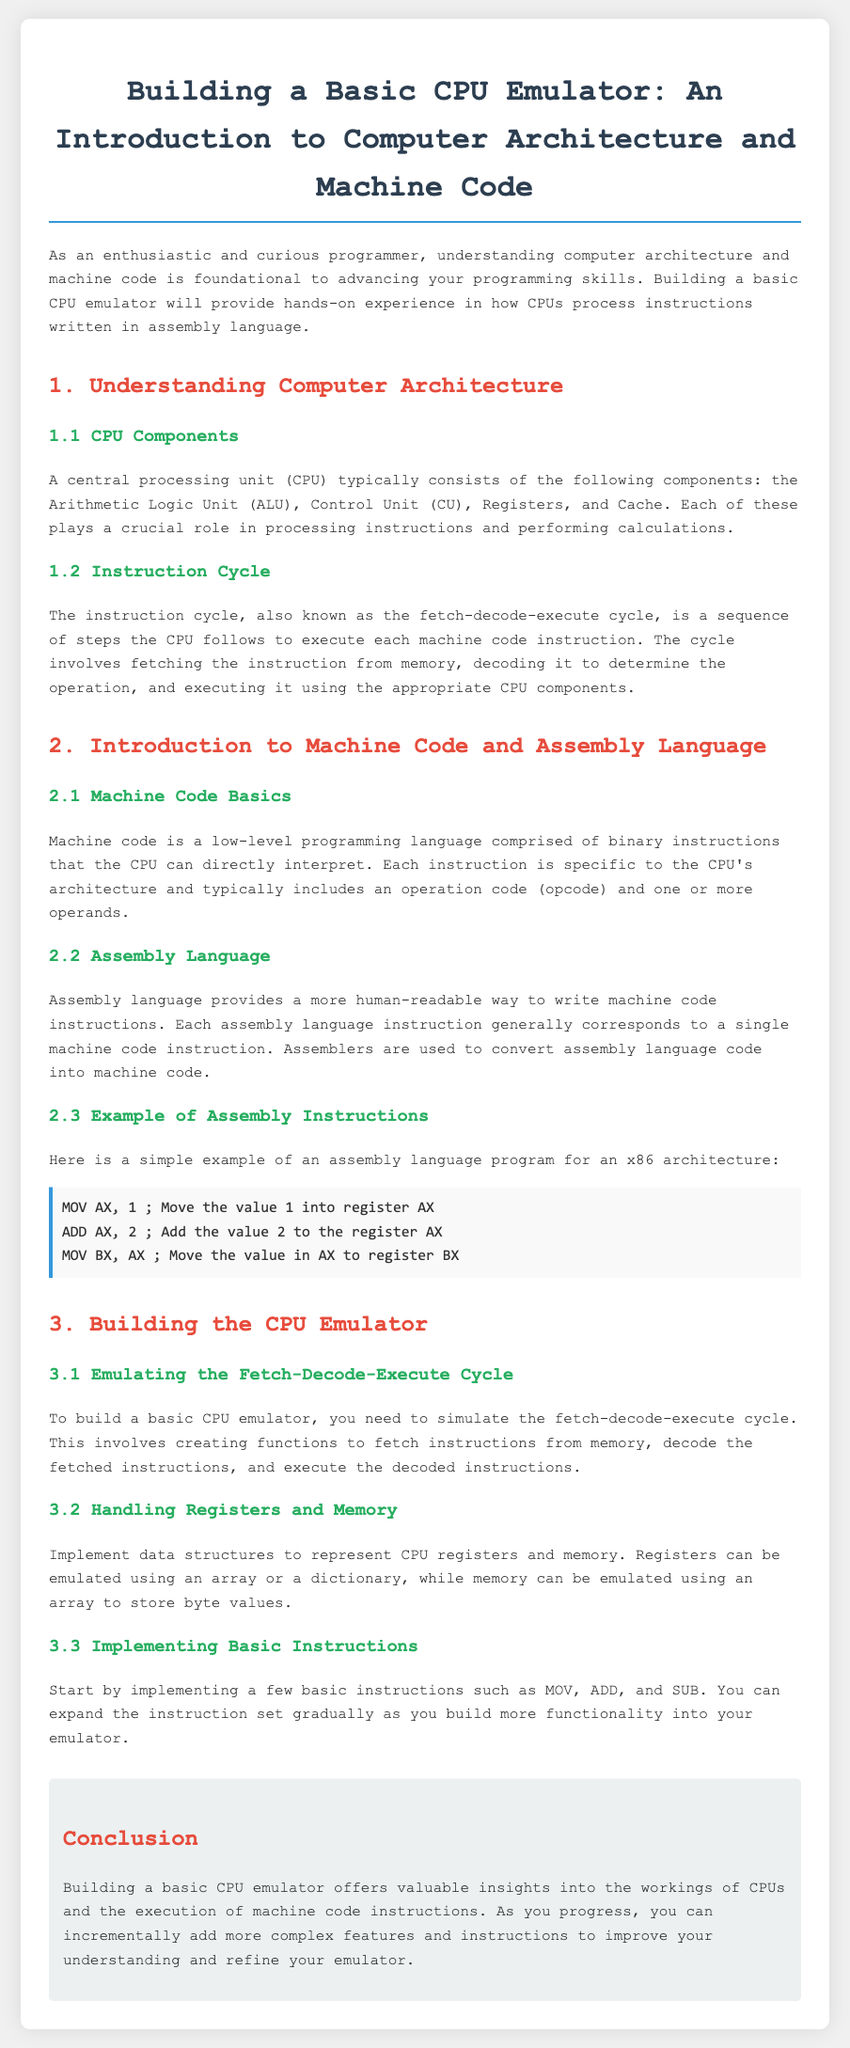What are the components of a CPU? The document lists the components of a CPU as the Arithmetic Logic Unit (ALU), Control Unit (CU), Registers, and Cache.
Answer: Arithmetic Logic Unit, Control Unit, Registers, Cache What cycle do CPUs follow to execute instructions? The document describes the instruction cycle which is known as the fetch-decode-execute cycle.
Answer: fetch-decode-execute cycle What does machine code consist of? The document states that machine code is comprised of binary instructions that the CPU can directly interpret.
Answer: binary instructions Give an example of an assembly instruction. The document provides an example instruction: "MOV AX, 1".
Answer: MOV AX, 1 What is the primary purpose of an assembler? The document explains that assemblers are used to convert assembly language code into machine code.
Answer: Convert assembly language to machine code Which instruction is used to add values in assembly language? The document mentions that the "ADD" instruction is used to add values.
Answer: ADD What data structures are suggested for registers and memory in the emulator? The document suggests using an array or a dictionary for registers and an array to store byte values for memory.
Answer: Array, dictionary What is the first instruction implemented in the CPU emulator? The document indicates that basic instructions like MOV, ADD, and SUB should be implemented first.
Answer: MOV, ADD, SUB What will building a CPU emulator help you understand? According to the document, building a CPU emulator offers valuable insights into how CPUs work and execute machine code instructions.
Answer: How CPUs work and execute machine code instructions 